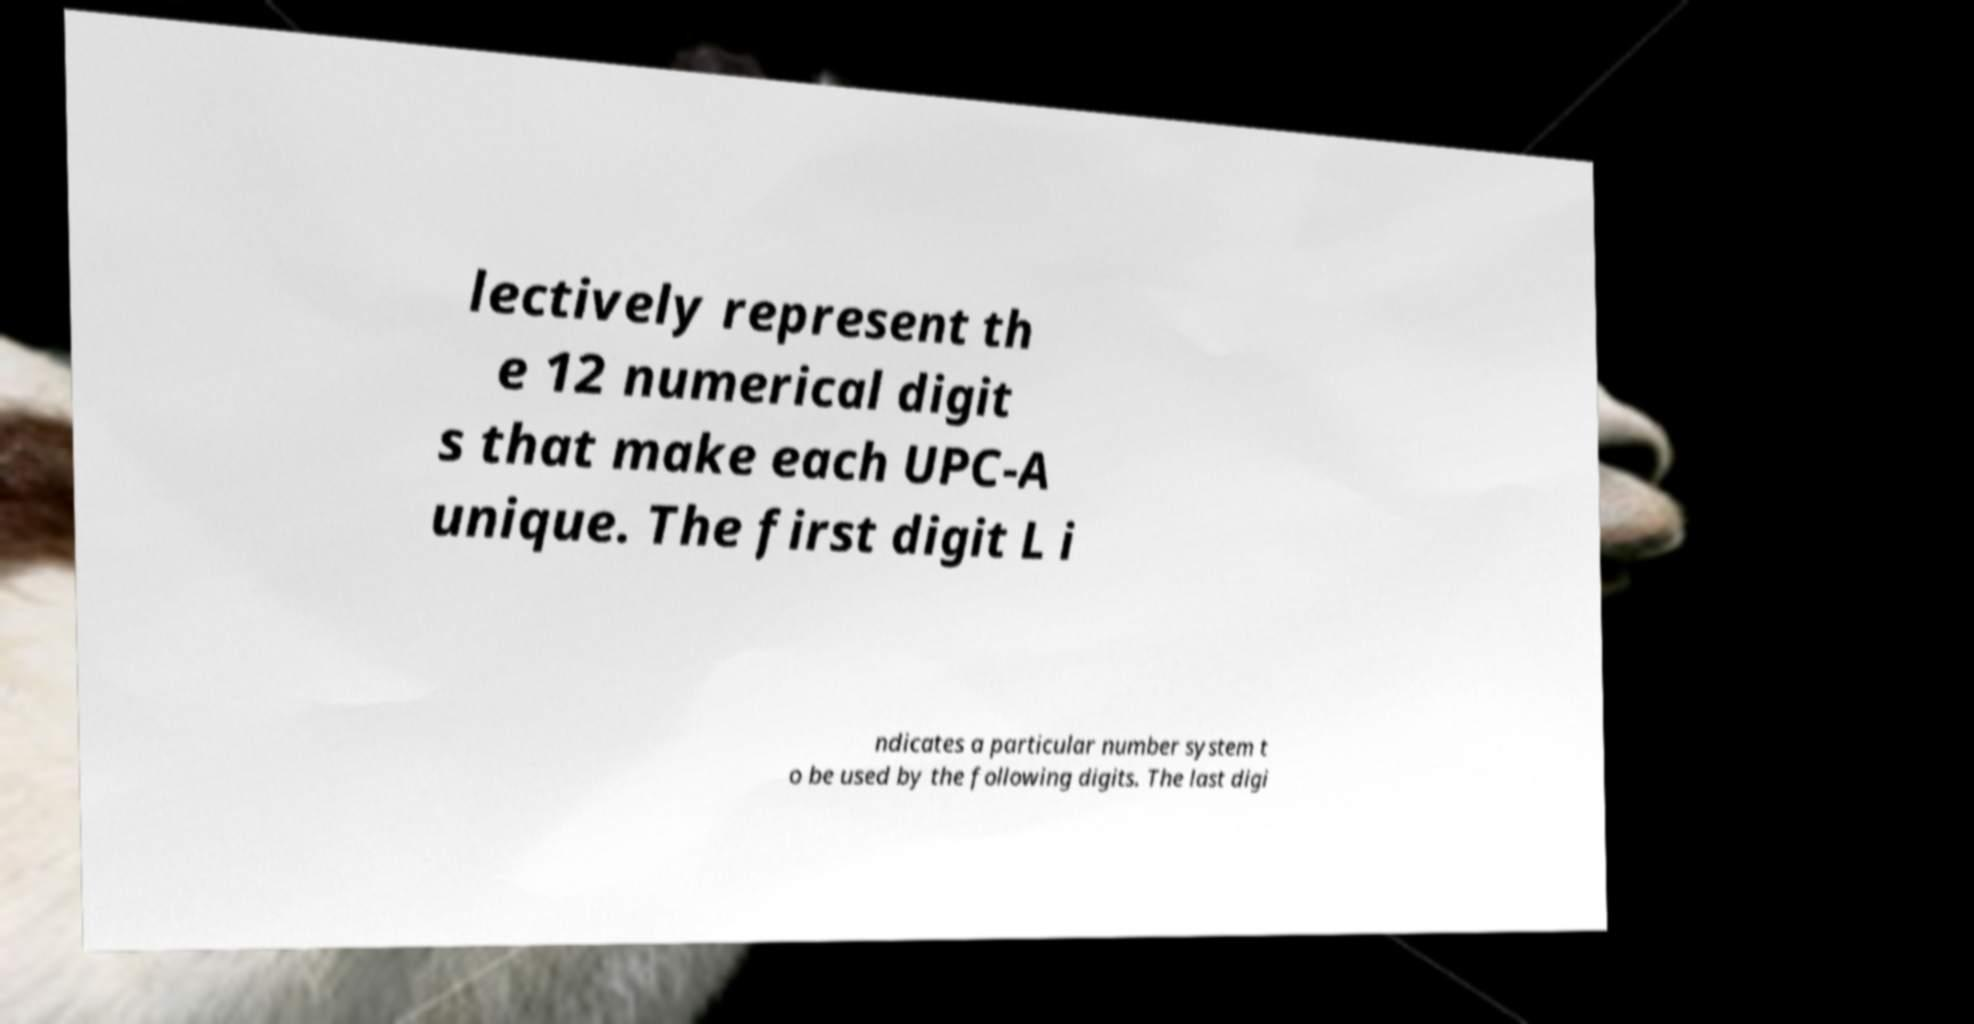Please identify and transcribe the text found in this image. lectively represent th e 12 numerical digit s that make each UPC-A unique. The first digit L i ndicates a particular number system t o be used by the following digits. The last digi 